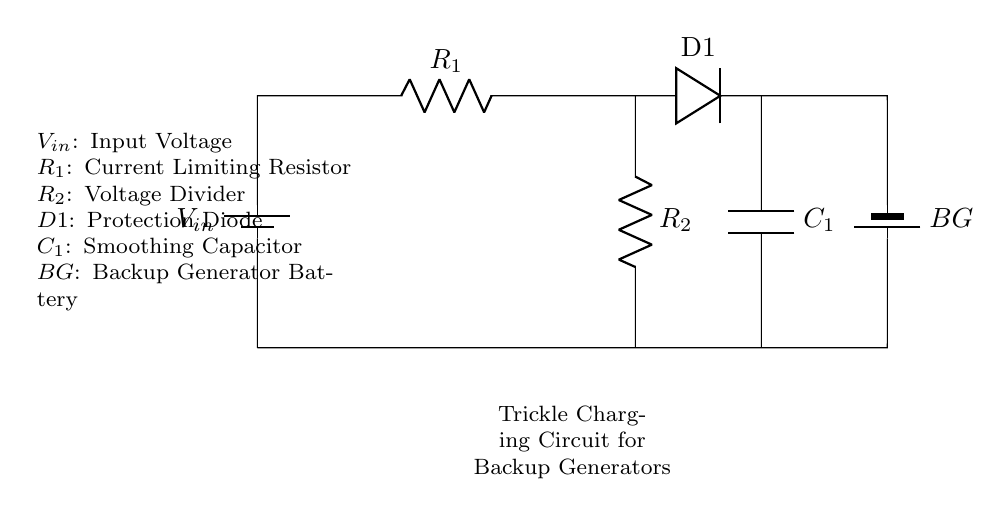What is the input voltage for this circuit? The input voltage is labeled as V_in in the circuit diagram, indicating where the voltage is supplied.
Answer: V_in What component is used to limit current in this circuit? The resistor labeled R_1 operates as a current limiting resistor, positioned in the path of the current flow to the battery.
Answer: R_1 How many resistors are present in the circuit? By counting the elements labeled R, we identify that there are two resistors, R_1 and R_2, in the circuit.
Answer: 2 What is the primary function of the protection diode? The diode labeled D1 prevents reverse current flow, ensuring that the backup generator battery does not discharge back into the circuit.
Answer: Protection What does C_1 represent in this circuit? The component labeled C_1 is a smoothing capacitor, which helps to stabilize the voltage and reduce ripples in the charging process.
Answer: Smoothing Capacitor What voltage does R_2 divide? R_2 is part of a voltage divider setup where it divides the voltage coming from V_in before reaching the backup generator battery.
Answer: V_in What is the purpose of the backup generator's battery? The backup generator's battery, labeled BG, serves as the storage device for the electrical energy, allowing for power during an outage.
Answer: Power storage 